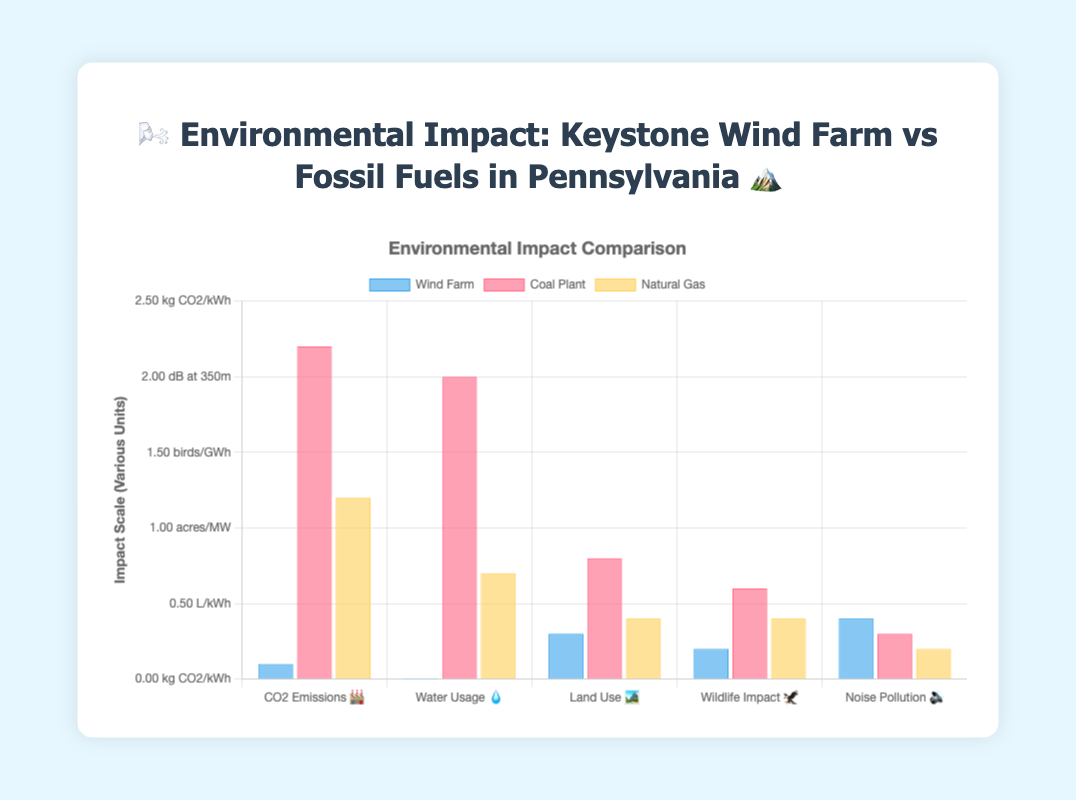Q: Which energy source has the highest CO2 emissions? 🌳🏭 The bar representing Coal Plant in the "CO2 Emissions 🏭" category is the tallest, indicating it has the highest CO2 emissions.
Answer: Coal Plant Q: How much water does the wind farm use per kWh compared to natural gas? 💧 The wind farm uses 0.001 L/kWh and natural gas uses 0.7 L/kWh. To find the difference, subtract the wind farm's usage from natural gas's usage: 0.7 - 0.001 = 0.699 L/kWh
Answer: 0.699 L/kWh Q: Between Coal Plant and Natural Gas, which has a greater impact on wildlife? 🦅 Compare the heights of the bars for "Wildlife Impact 🦅"; Coal Plant has a higher value (0.6 birds/GWh) compared to Natural Gas (0.4 birds/GWh).
Answer: Coal Plant Q: What is the unit used for measuring CO2 emissions? 🌳🏭 The y-axis label annotations indicate the unit, which is "kg CO2/kWh".
Answer: kg CO2/kWh Q: Which energy source has the least noise pollution? 🔊 The "Noise Pollution 🔊" bar for Natural Gas is the shortest among the three energy sources, indicating it has the least noise pollution measured in dB at 350m.
Answer: Natural Gas Q: How much more land does a wind farm use per MW compared to a natural gas plant? 🏞️ The wind farm uses 0.3 acres/MW and natural gas uses 0.4 acres/MW. Subtract the wind farm's land use from natural gas's land use: 0.4 - 0.3 = 0.1 acres/MW
Answer: 0.1 acres/MW Q: Is the noise pollution from wind farms higher or lower compared to coal plants? 🔊 The "Noise Pollution 🔊" bar for Wind Farm is higher (0.4 dB) compared to the Coal Plant (0.3 dB), indicating higher noise pollution from wind farms.
Answer: Higher Q: What is the overall environmental impact of wind farms relative to fossil fuels? 🌳🏭 Wind farms have significantly lower CO2 emissions, water usage, and wildlife impact compared to both coal and natural gas. However, they use more land and have slightly higher noise pollution than coal plants but less than natural gas.
Answer: Lower overall impact Q: Which source has the least impact on water usage? 💧 The "Water Usage 💧" bar for Wind Farm is the shortest, showing 0.001 L/kWh, which is significantly lower compared to both Coal and Natural Gas plants.
Answer: Wind Farm 